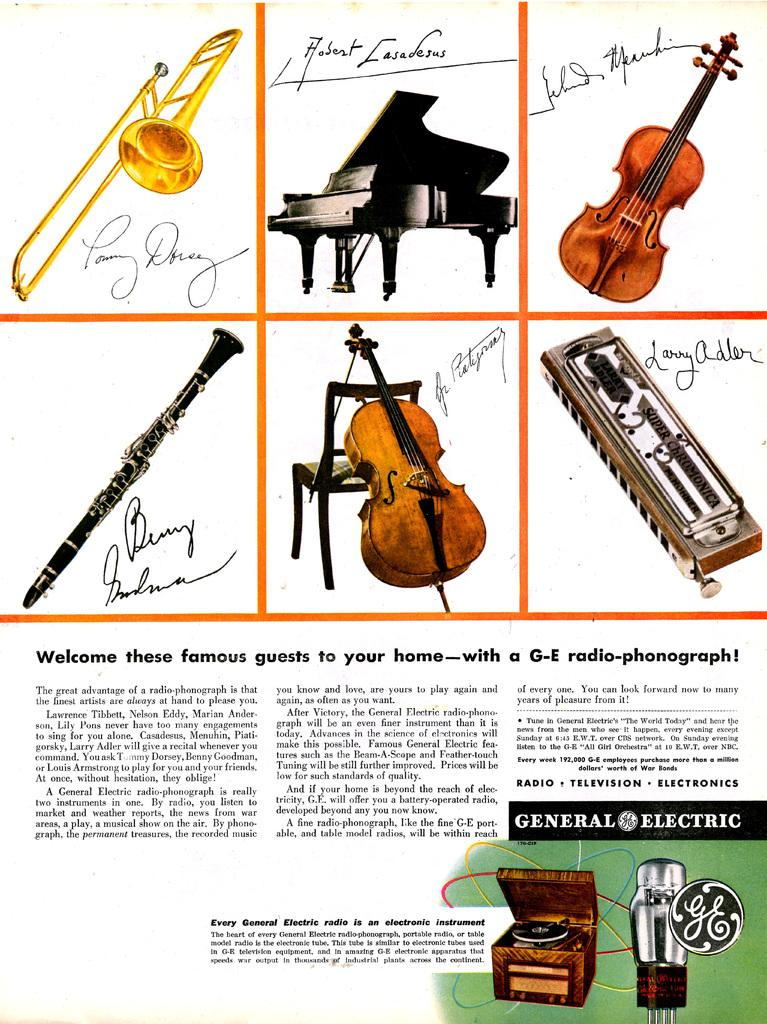What is featured in the image? There is a poster in the image. What is depicted on the poster? The poster contains different musical instruments. What is the tendency of the poster to change its color throughout the day? The provided facts do not mention any information about the poster's color or its tendency to change throughout the day. 